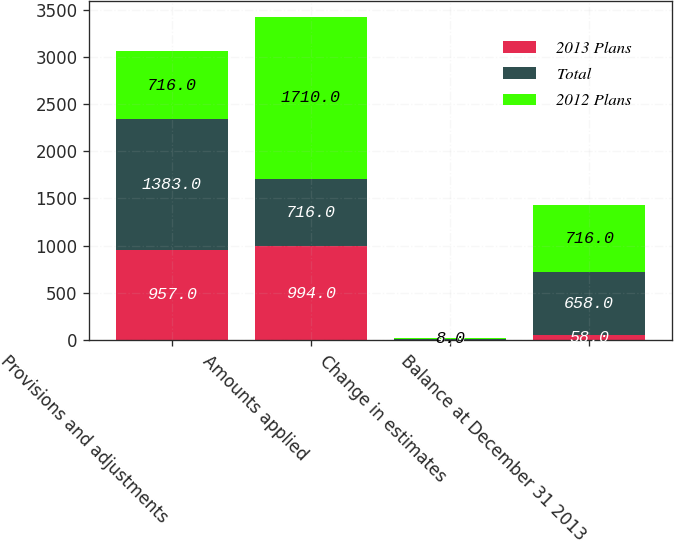<chart> <loc_0><loc_0><loc_500><loc_500><stacked_bar_chart><ecel><fcel>Provisions and adjustments<fcel>Amounts applied<fcel>Change in estimates<fcel>Balance at December 31 2013<nl><fcel>2013 Plans<fcel>957<fcel>994<fcel>1<fcel>58<nl><fcel>Total<fcel>1383<fcel>716<fcel>9<fcel>658<nl><fcel>2012 Plans<fcel>716<fcel>1710<fcel>8<fcel>716<nl></chart> 